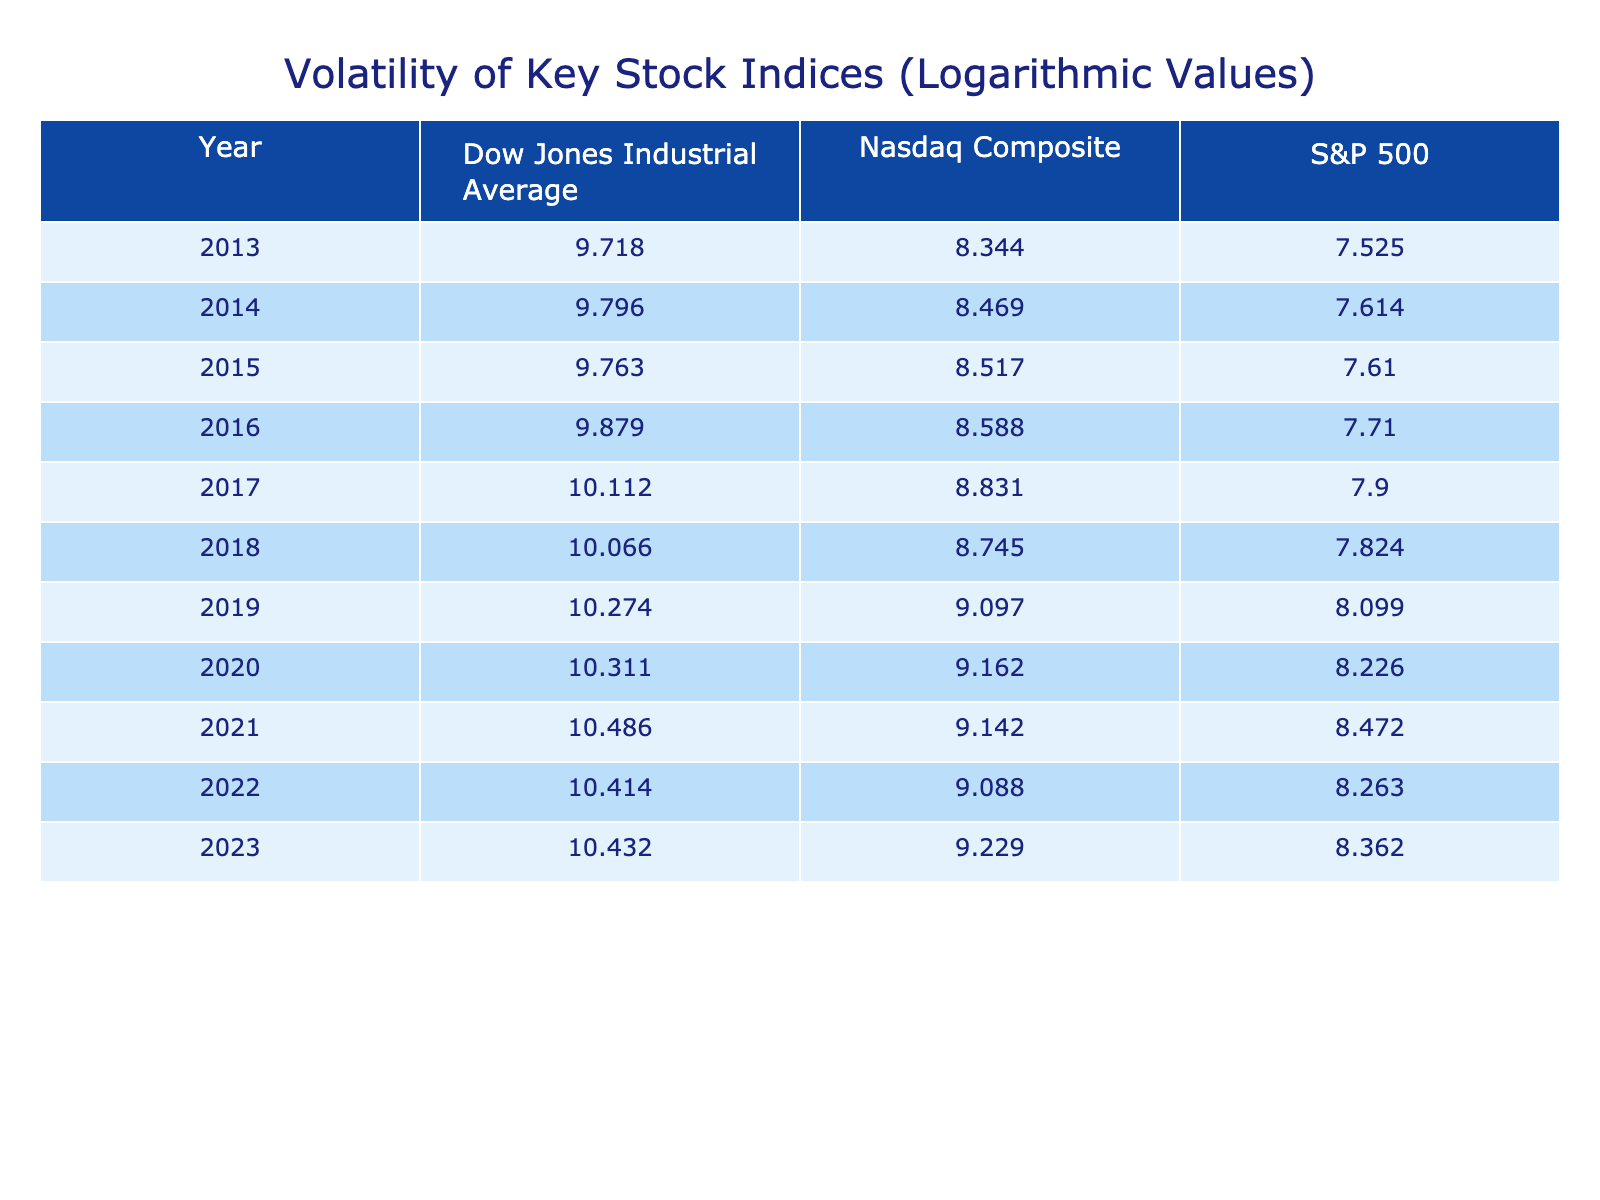What was the closing price of S&P 500 in 2015? The table lists the closing price for S&P 500 in 2015 as 2043.94.
Answer: 2043.94 In which year did the Nasdaq Composite reach a closing price above 13,000? According to the table, the Nasdaq Composite crossed 13,000 in 2021 with a closing price of 13914.77.
Answer: 2021 What was the average logarithmic value for the Dow Jones Industrial Average over the last decade? The Dow Jones values for each year are: 9.718, 9.796, 9.763, 9.879, 10.112, 10.066, 10.274, 10.311, 10.486, 10.414, 10.432. The sum is 109.633 and there are 11 values; therefore, the average is 109.633 / 11 = 9.976.
Answer: 9.976 True or False: The S&P 500 had a better performance than the Nasdaq Composite in 2018 based on the logarithmic values. In 2018, the logarithmic value for S&P 500 is 7.824, while for Nasdaq Composite it is 8.745. Since 7.824 < 8.745, the statement is false.
Answer: False What is the difference in logarithmic value between the highest closing price years for Nasdaq Composite and S&P 500? The highest for Nasdaq was in 2023 (9.229) and for S&P 500, it was in 2021 (8.472). The difference is 9.229 - 8.472 = 0.757.
Answer: 0.757 In which year did the Dow Jones Industrial Average close above 35,000? The data shows that the highest closing price for Dow Jones occurred in 2021 (36338.30), and it did not close above 35,000 in any of the provided years.
Answer: None What was the percentage increase in the logarithmic value of the S&P 500 from 2013 to 2021? The logarithmic value in 2013 was 7.525, and in 2021 it was 8.472. The difference is 8.472 - 7.525 = 0.947. To find the percentage, (0.947 / 7.525) * 100 = 12.59%.
Answer: 12.59% What was the closing price of the Dow Jones in 2020 compared to its value in 2019? According to the table, the closing price was 30114.62 in 2020 and 28892.55 in 2019, indicating an increase of 30114.62 - 28892.55 = 2222.07. This shows it was higher in 2020.
Answer: Higher in 2020 